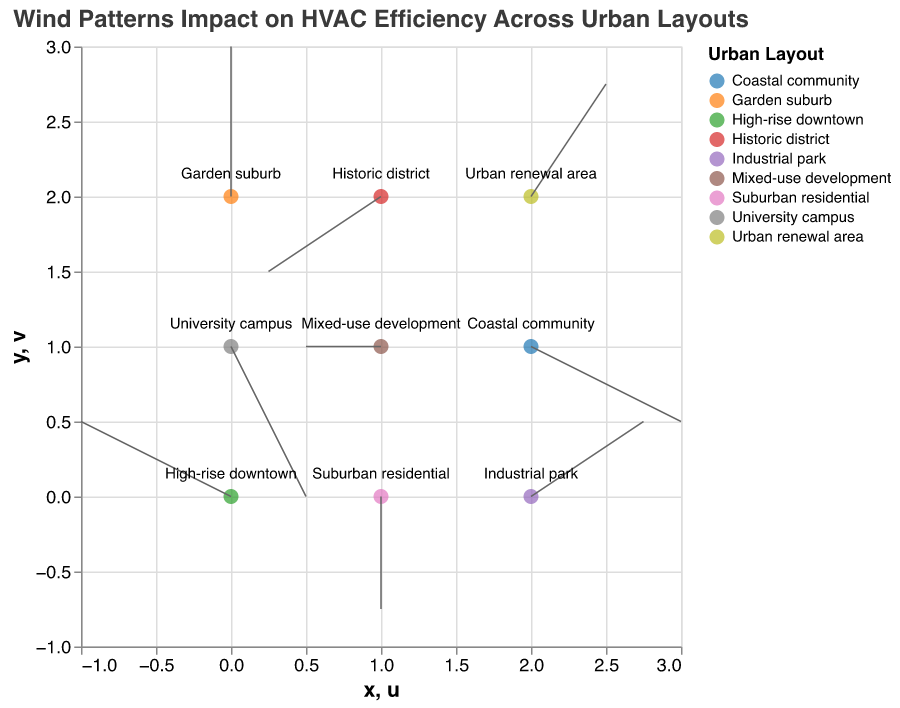What is the title of the figure? The title of the figure is displayed at the top, indicating the main topic the visualization covers.
Answer: Wind Patterns Impact on HVAC Efficiency Across Urban Layouts Which urban layout shows the highest wind magnitude? By hovering over the points in the visualization or referring to the dataset, the urban layouts and their corresponding wind magnitudes can be identified. The highest magnitude is 2.2, associated with "High-rise downtown," "University campus," and "Coastal community."
Answer: High-rise downtown, University campus, Coastal community Which urban layout has a predominantly eastward wind direction? Wind direction is determined by the u (horizontal) component. Eastward direction indicates a positive u value. Checking the data, we see "Industrial park" and "Urban renewal area" have positive u values.
Answer: Industrial park, Urban renewal area How many data points represent different urban layouts? Each point in the plot represents a unique urban layout. Counting the unique layouts in the dataset or the legend provides this number.
Answer: 9 Which urban layouts experience wind moving mostly in the southward direction? Southward wind means a negative v (vertical) component. By checking the data, we see "Suburban residential," "University campus," "Coastal community," and "Historic district" have negative v values.
Answer: Suburban residential, University campus, Coastal community, Historic district In which direction does the wind blow in the "Garden suburb" area? The wind direction in "Garden suburb" is given by the u and v values. The data shows u=0 and v=2, meaning the wind blows northward.
Answer: Northward What is the magnitude of the wind in the "Mixed-use development" area? Hovering over the corresponding point or referring to the dataset allows us to see that the wind magnitude in "Mixed-use development" is 1.0.
Answer: 1.0 Which urban layout has a wind direction vector of (-1, 0)? The wind direction vector (-1, 0) indicates the horizontal component u=-1 and vertical component v=0. The dataset shows this vector corresponds to "Mixed-use development."
Answer: Mixed-use development Compare the wind magnitudes between "Suburban residential" and "Coastal community.” Referring to the dataset, "Suburban residential" has a magnitude of 1.5, while "Coastal community" has a magnitude of 2.2.
Answer: Coastal community > Suburban residential 